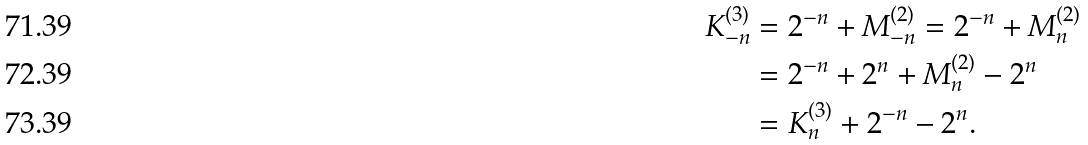Convert formula to latex. <formula><loc_0><loc_0><loc_500><loc_500>K _ { - n } ^ { ( 3 ) } & = 2 ^ { - n } + M _ { - n } ^ { ( 2 ) } = 2 ^ { - n } + M _ { n } ^ { ( 2 ) } \\ & = 2 ^ { - n } + 2 ^ { n } + M _ { n } ^ { ( 2 ) } - 2 ^ { n } \\ & = K _ { n } ^ { ( 3 ) } + 2 ^ { - n } - 2 ^ { n } .</formula> 